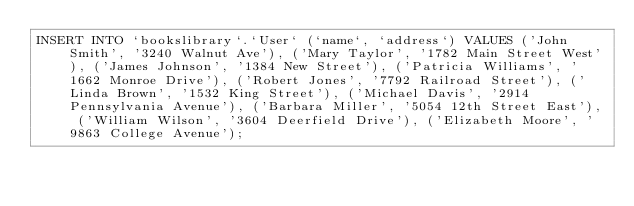Convert code to text. <code><loc_0><loc_0><loc_500><loc_500><_SQL_>INSERT INTO `bookslibrary`.`User` (`name`, `address`) VALUES ('John Smith', '3240 Walnut Ave'), ('Mary Taylor', '1782 Main Street West'), ('James Johnson', '1384 New Street'), ('Patricia Williams', '1662 Monroe Drive'), ('Robert Jones', '7792 Railroad Street'), ('Linda Brown', '1532 King Street'), ('Michael Davis', '2914 Pennsylvania Avenue'), ('Barbara Miller', '5054 12th Street East'), ('William Wilson', '3604 Deerfield Drive'), ('Elizabeth Moore', '9863 College Avenue');</code> 